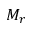<formula> <loc_0><loc_0><loc_500><loc_500>M _ { r }</formula> 